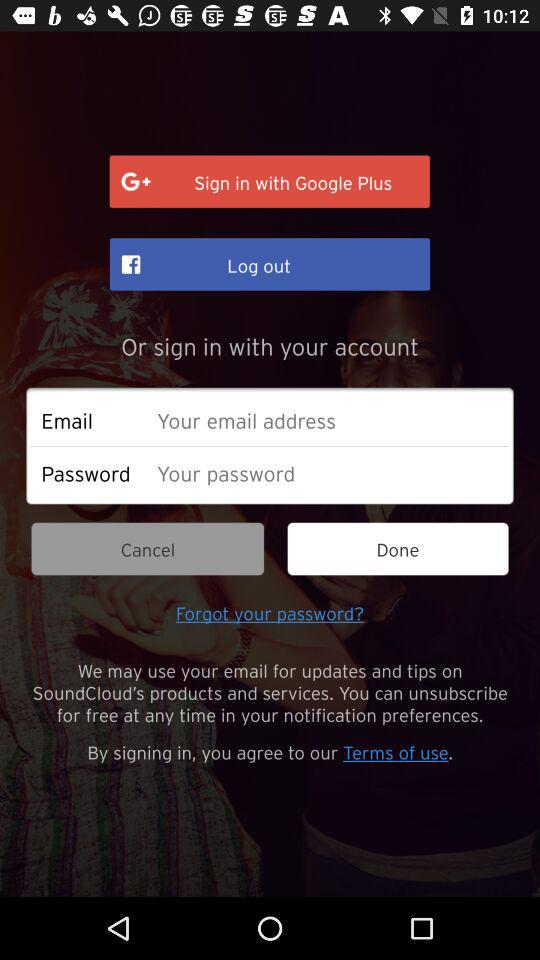What are the options through which we can sign in? The options are "Google Plus" and "Email". 